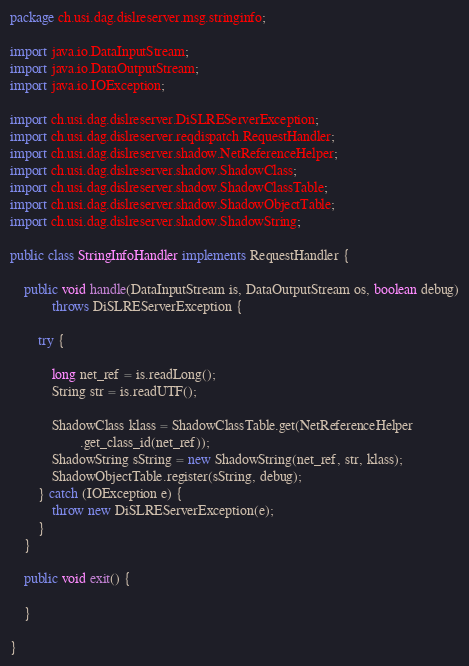<code> <loc_0><loc_0><loc_500><loc_500><_Java_>package ch.usi.dag.dislreserver.msg.stringinfo;

import java.io.DataInputStream;
import java.io.DataOutputStream;
import java.io.IOException;

import ch.usi.dag.dislreserver.DiSLREServerException;
import ch.usi.dag.dislreserver.reqdispatch.RequestHandler;
import ch.usi.dag.dislreserver.shadow.NetReferenceHelper;
import ch.usi.dag.dislreserver.shadow.ShadowClass;
import ch.usi.dag.dislreserver.shadow.ShadowClassTable;
import ch.usi.dag.dislreserver.shadow.ShadowObjectTable;
import ch.usi.dag.dislreserver.shadow.ShadowString;

public class StringInfoHandler implements RequestHandler {

    public void handle(DataInputStream is, DataOutputStream os, boolean debug)
            throws DiSLREServerException {

        try {

            long net_ref = is.readLong();
            String str = is.readUTF();

            ShadowClass klass = ShadowClassTable.get(NetReferenceHelper
                    .get_class_id(net_ref));
            ShadowString sString = new ShadowString(net_ref, str, klass);
            ShadowObjectTable.register(sString, debug);
        } catch (IOException e) {
            throw new DiSLREServerException(e);
        }
    }

    public void exit() {

    }

}
</code> 